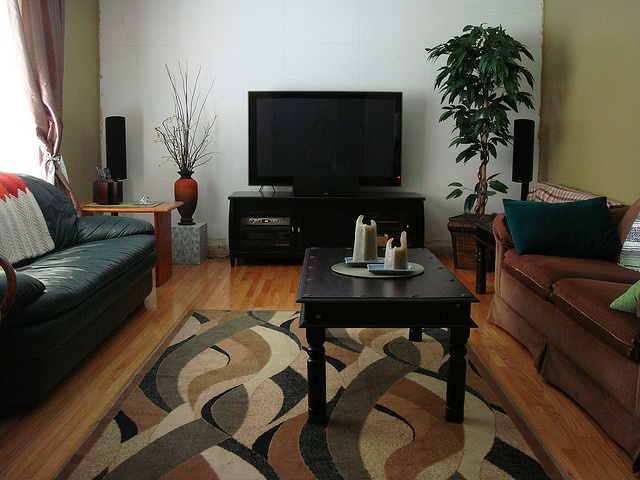Describe the objects in this image and their specific colors. I can see couch in white, black, maroon, and gray tones, couch in white, black, gray, darkgray, and teal tones, potted plant in white, black, darkgray, gray, and darkgreen tones, tv in white, black, and gray tones, and potted plant in white, lightgray, darkgray, black, and gray tones in this image. 